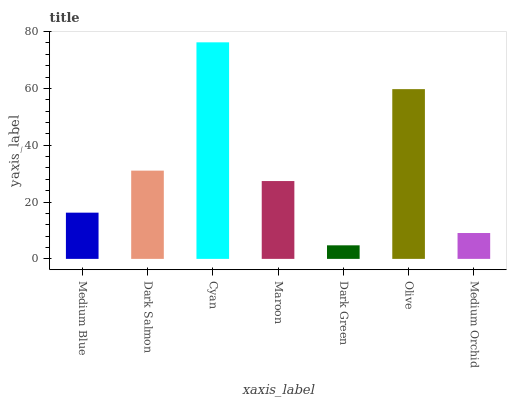Is Dark Green the minimum?
Answer yes or no. Yes. Is Cyan the maximum?
Answer yes or no. Yes. Is Dark Salmon the minimum?
Answer yes or no. No. Is Dark Salmon the maximum?
Answer yes or no. No. Is Dark Salmon greater than Medium Blue?
Answer yes or no. Yes. Is Medium Blue less than Dark Salmon?
Answer yes or no. Yes. Is Medium Blue greater than Dark Salmon?
Answer yes or no. No. Is Dark Salmon less than Medium Blue?
Answer yes or no. No. Is Maroon the high median?
Answer yes or no. Yes. Is Maroon the low median?
Answer yes or no. Yes. Is Medium Orchid the high median?
Answer yes or no. No. Is Dark Green the low median?
Answer yes or no. No. 